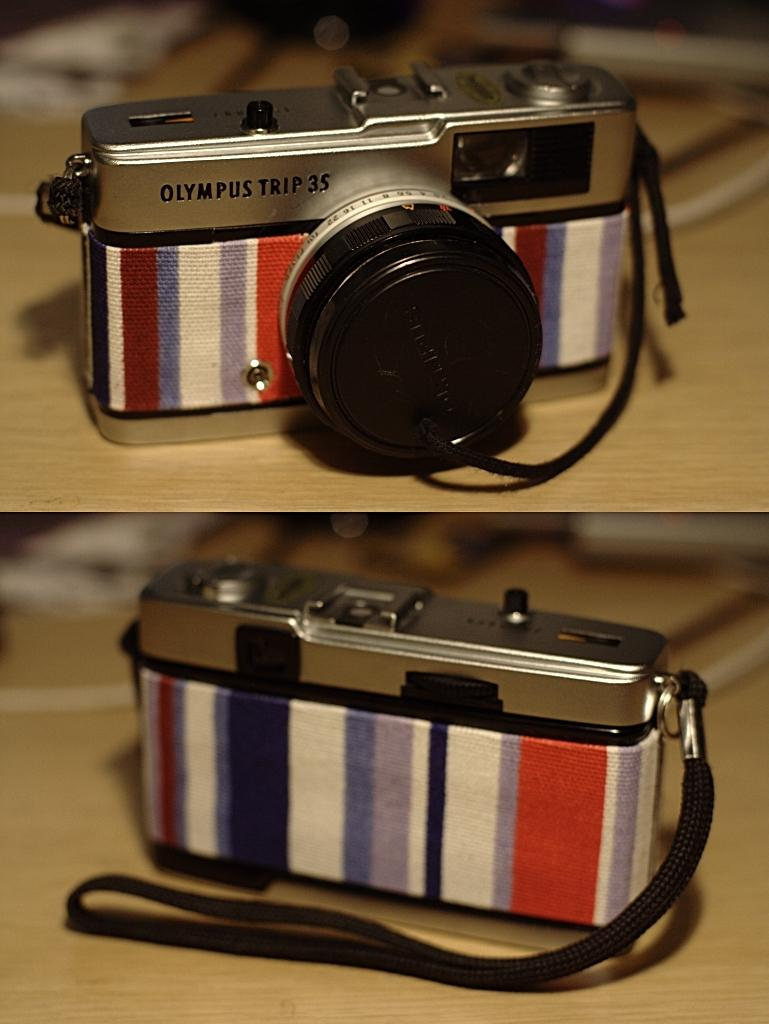What object is the main subject of the image? There is a camera in the image. Where is the camera located? The camera is on a table. How is the image presented? The image is a grid image. What type of birds can be seen flying in the image? There are no birds present in the image; it features a camera on a table. How does the camera capture the attention of the viewer in the image? The image does not show the camera capturing anyone's attention; it is a still image of a camera on a table. 